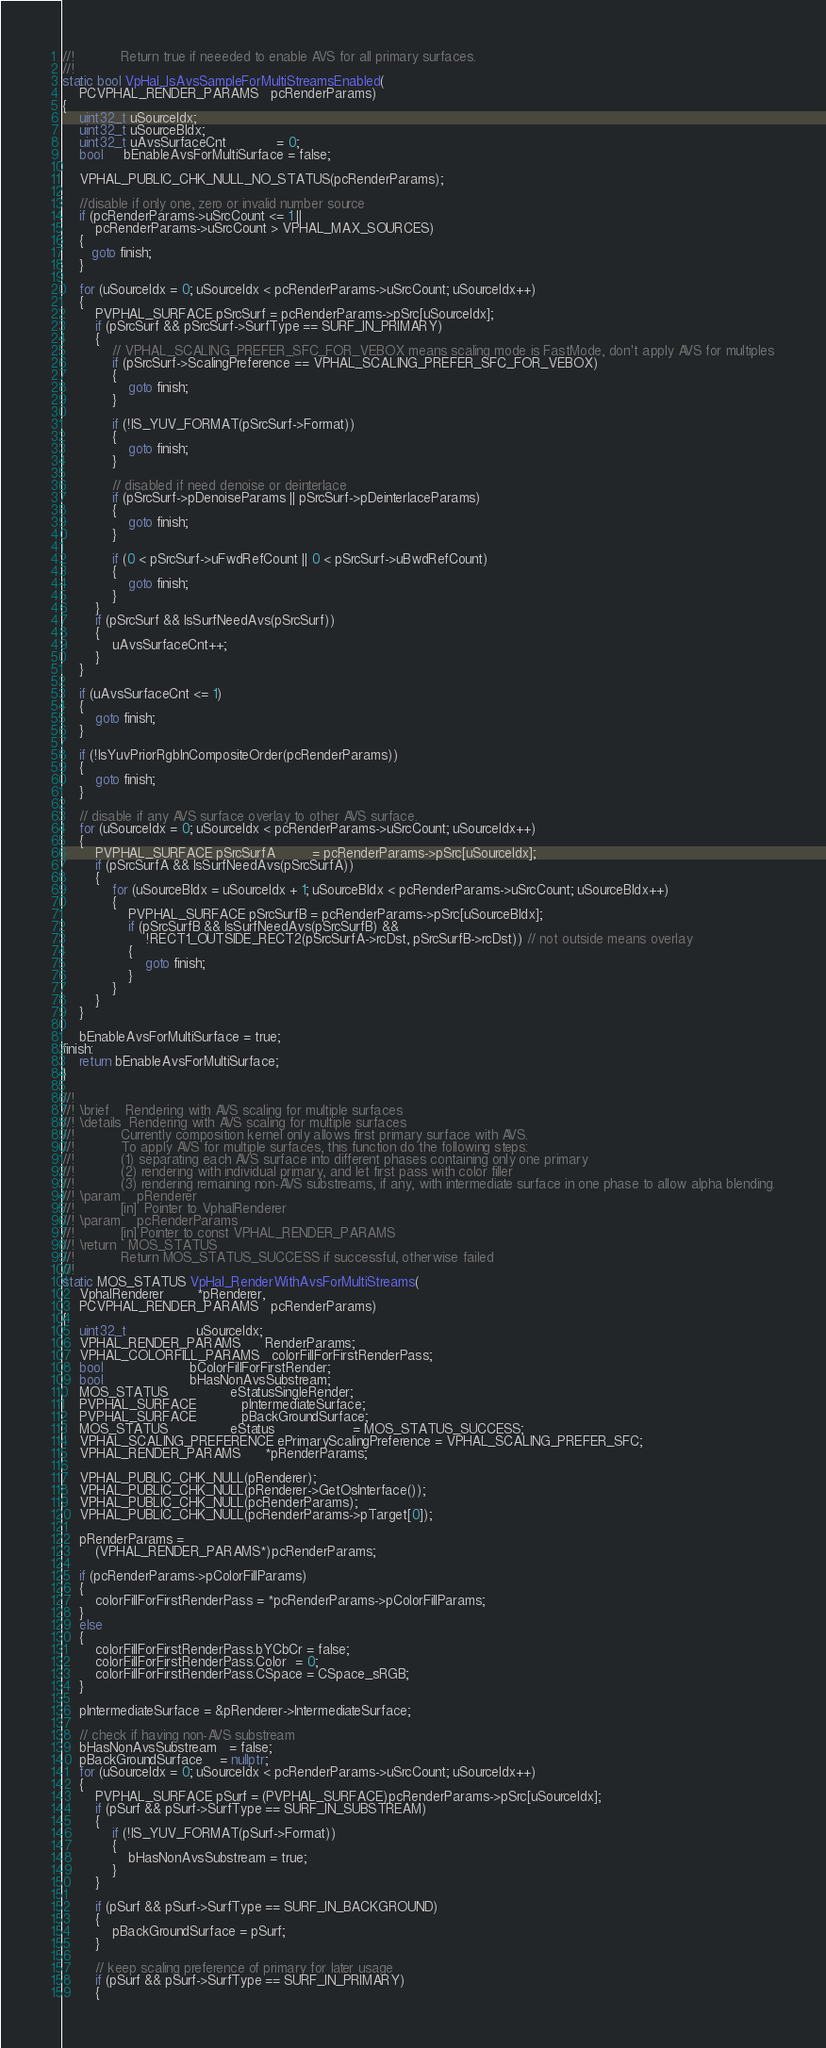<code> <loc_0><loc_0><loc_500><loc_500><_C++_>//!           Return true if neeeded to enable AVS for all primary surfaces.
//!
static bool VpHal_IsAvsSampleForMultiStreamsEnabled(
    PCVPHAL_RENDER_PARAMS   pcRenderParams)
{
    uint32_t uSourceIdx;
    uint32_t uSourceBIdx;
    uint32_t uAvsSurfaceCnt            = 0;
    bool     bEnableAvsForMultiSurface = false;

    VPHAL_PUBLIC_CHK_NULL_NO_STATUS(pcRenderParams);

    //disable if only one, zero or invalid number source
    if (pcRenderParams->uSrcCount <= 1 ||
        pcRenderParams->uSrcCount > VPHAL_MAX_SOURCES)
    {
       goto finish;
    }

    for (uSourceIdx = 0; uSourceIdx < pcRenderParams->uSrcCount; uSourceIdx++)
    {
        PVPHAL_SURFACE pSrcSurf = pcRenderParams->pSrc[uSourceIdx];
        if (pSrcSurf && pSrcSurf->SurfType == SURF_IN_PRIMARY)
        {
            // VPHAL_SCALING_PREFER_SFC_FOR_VEBOX means scaling mode is FastMode, don't apply AVS for multiples
            if (pSrcSurf->ScalingPreference == VPHAL_SCALING_PREFER_SFC_FOR_VEBOX)
            {
                goto finish;
            }

            if (!IS_YUV_FORMAT(pSrcSurf->Format))
            {
                goto finish;
            }

            // disabled if need denoise or deinterlace
            if (pSrcSurf->pDenoiseParams || pSrcSurf->pDeinterlaceParams)
            {
                goto finish;
            }

            if (0 < pSrcSurf->uFwdRefCount || 0 < pSrcSurf->uBwdRefCount)
            {
                goto finish;
            }
        }
        if (pSrcSurf && IsSurfNeedAvs(pSrcSurf))
        {
            uAvsSurfaceCnt++;
        }
    }

    if (uAvsSurfaceCnt <= 1)
    {
        goto finish;
    }

    if (!IsYuvPriorRgbInCompositeOrder(pcRenderParams))
    {
        goto finish;
    }
 
    // disable if any AVS surface overlay to other AVS surface.
    for (uSourceIdx = 0; uSourceIdx < pcRenderParams->uSrcCount; uSourceIdx++)
    {
        PVPHAL_SURFACE pSrcSurfA         = pcRenderParams->pSrc[uSourceIdx];
        if (pSrcSurfA && IsSurfNeedAvs(pSrcSurfA))
        {
            for (uSourceBIdx = uSourceIdx + 1; uSourceBIdx < pcRenderParams->uSrcCount; uSourceBIdx++)
            {
                PVPHAL_SURFACE pSrcSurfB = pcRenderParams->pSrc[uSourceBIdx];
                if (pSrcSurfB && IsSurfNeedAvs(pSrcSurfB) &&
                    !RECT1_OUTSIDE_RECT2(pSrcSurfA->rcDst, pSrcSurfB->rcDst)) // not outside means overlay
                {
                    goto finish;
                }
            }
        }
    }

    bEnableAvsForMultiSurface = true;
finish:
    return bEnableAvsForMultiSurface;
}

//!
//! \brief    Rendering with AVS scaling for multiple surfaces
//! \details  Rendering with AVS scaling for multiple surfaces
//!           Currently composition kernel only allows first primary surface with AVS.
//!           To apply AVS for multiple surfaces, this function do the following steps:
//!           (1) separating each AVS surface into different phases containing only one primary
//!           (2) rendering with individual primary, and let first pass with color filler
//!           (3) rendering remaining non-AVS substreams, if any, with intermediate surface in one phase to allow alpha blending.
//! \param    pRenderer
//!           [in]  Pointer to VphalRenderer
//! \param    pcRenderParams
//!           [in] Pointer to const VPHAL_RENDER_PARAMS
//! \return   MOS_STATUS
//!           Return MOS_STATUS_SUCCESS if successful, otherwise failed
//!
static MOS_STATUS VpHal_RenderWithAvsForMultiStreams(
    VphalRenderer        *pRenderer,
    PCVPHAL_RENDER_PARAMS   pcRenderParams)
{
    uint32_t                 uSourceIdx;
    VPHAL_RENDER_PARAMS      RenderParams;
    VPHAL_COLORFILL_PARAMS   colorFillForFirstRenderPass;
    bool                     bColorFillForFirstRender;
    bool                     bHasNonAvsSubstream;
    MOS_STATUS               eStatusSingleRender;
    PVPHAL_SURFACE           pIntermediateSurface;
    PVPHAL_SURFACE           pBackGroundSurface;
    MOS_STATUS               eStatus                   = MOS_STATUS_SUCCESS;
    VPHAL_SCALING_PREFERENCE ePrimaryScalingPreference = VPHAL_SCALING_PREFER_SFC;
    VPHAL_RENDER_PARAMS      *pRenderParams;

    VPHAL_PUBLIC_CHK_NULL(pRenderer);
    VPHAL_PUBLIC_CHK_NULL(pRenderer->GetOsInterface());
    VPHAL_PUBLIC_CHK_NULL(pcRenderParams);
    VPHAL_PUBLIC_CHK_NULL(pcRenderParams->pTarget[0]);

    pRenderParams =
        (VPHAL_RENDER_PARAMS*)pcRenderParams;

    if (pcRenderParams->pColorFillParams)
    {
        colorFillForFirstRenderPass = *pcRenderParams->pColorFillParams;
    }
    else
    {
        colorFillForFirstRenderPass.bYCbCr = false;
        colorFillForFirstRenderPass.Color  = 0;
        colorFillForFirstRenderPass.CSpace = CSpace_sRGB;
    }

    pIntermediateSurface = &pRenderer->IntermediateSurface;

    // check if having non-AVS substream
    bHasNonAvsSubstream   = false;
    pBackGroundSurface    = nullptr;
    for (uSourceIdx = 0; uSourceIdx < pcRenderParams->uSrcCount; uSourceIdx++)
    {
        PVPHAL_SURFACE pSurf = (PVPHAL_SURFACE)pcRenderParams->pSrc[uSourceIdx];
        if (pSurf && pSurf->SurfType == SURF_IN_SUBSTREAM)
        {
            if (!IS_YUV_FORMAT(pSurf->Format))
            {
                bHasNonAvsSubstream = true;
            }
        }

        if (pSurf && pSurf->SurfType == SURF_IN_BACKGROUND)
        {
            pBackGroundSurface = pSurf;
        }

        // keep scaling preference of primary for later usage
        if (pSurf && pSurf->SurfType == SURF_IN_PRIMARY)
        {</code> 